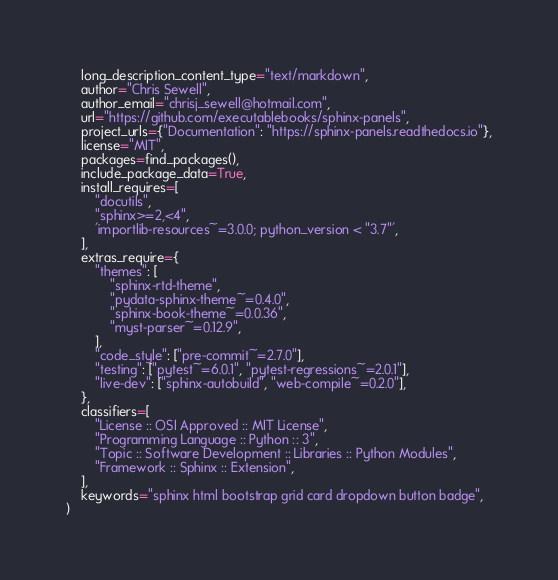<code> <loc_0><loc_0><loc_500><loc_500><_Python_>    long_description_content_type="text/markdown",
    author="Chris Sewell",
    author_email="chrisj_sewell@hotmail.com",
    url="https://github.com/executablebooks/sphinx-panels",
    project_urls={"Documentation": "https://sphinx-panels.readthedocs.io"},
    license="MIT",
    packages=find_packages(),
    include_package_data=True,
    install_requires=[
        "docutils",
        "sphinx>=2,<4",
        'importlib-resources~=3.0.0; python_version < "3.7"',
    ],
    extras_require={
        "themes": [
            "sphinx-rtd-theme",
            "pydata-sphinx-theme~=0.4.0",
            "sphinx-book-theme~=0.0.36",
            "myst-parser~=0.12.9",
        ],
        "code_style": ["pre-commit~=2.7.0"],
        "testing": ["pytest~=6.0.1", "pytest-regressions~=2.0.1"],
        "live-dev": ["sphinx-autobuild", "web-compile~=0.2.0"],
    },
    classifiers=[
        "License :: OSI Approved :: MIT License",
        "Programming Language :: Python :: 3",
        "Topic :: Software Development :: Libraries :: Python Modules",
        "Framework :: Sphinx :: Extension",
    ],
    keywords="sphinx html bootstrap grid card dropdown button badge",
)
</code> 